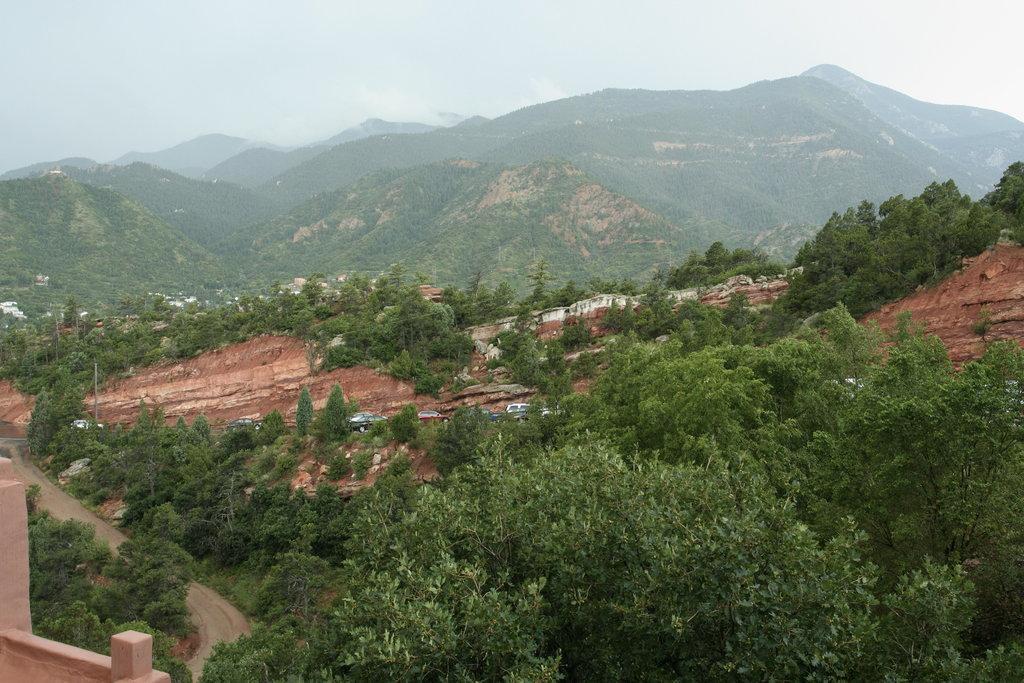How would you summarize this image in a sentence or two? In this image I can see there are so many mountains which are covered with trees. 